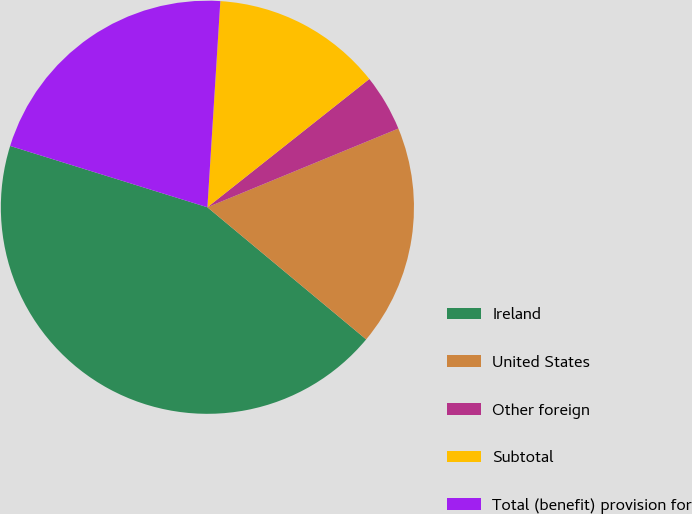<chart> <loc_0><loc_0><loc_500><loc_500><pie_chart><fcel>Ireland<fcel>United States<fcel>Other foreign<fcel>Subtotal<fcel>Total (benefit) provision for<nl><fcel>43.75%<fcel>17.27%<fcel>4.44%<fcel>13.34%<fcel>21.2%<nl></chart> 